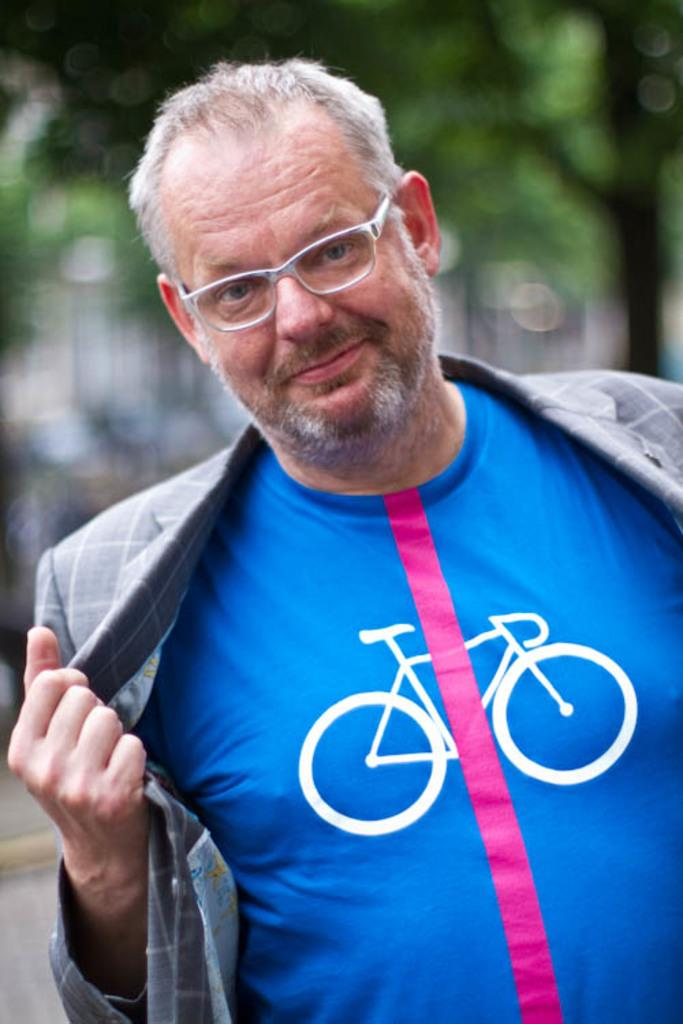Who or what is present in the image? There is a person in the image. What is the person wearing? The person is wearing a blue and gray color dress. What can be seen in the background of the image? There are trees in the background of the image. What is the color of the trees? The trees are green in color. How does the person show respect to the authority in the image? There is no indication of authority or respect in the image; it only shows a person wearing a blue and gray dress with trees in the background. 